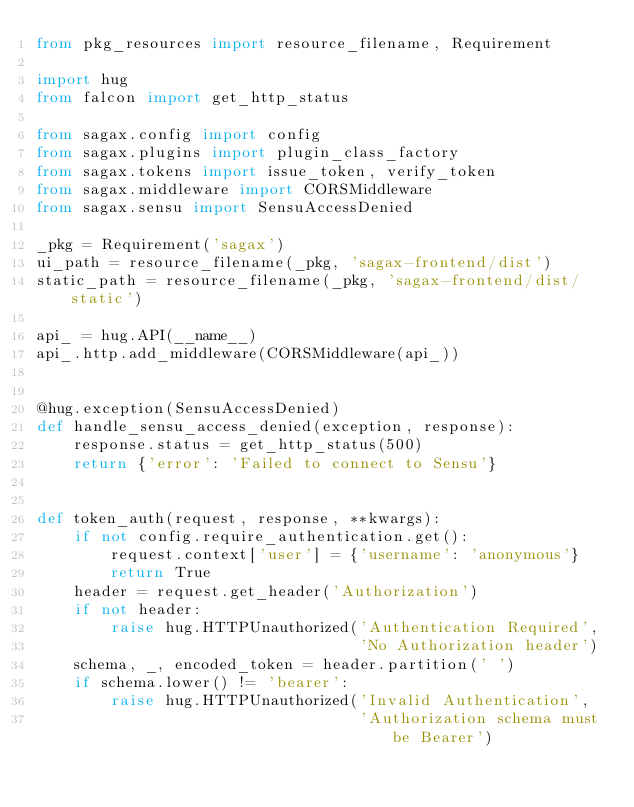Convert code to text. <code><loc_0><loc_0><loc_500><loc_500><_Python_>from pkg_resources import resource_filename, Requirement

import hug
from falcon import get_http_status

from sagax.config import config
from sagax.plugins import plugin_class_factory
from sagax.tokens import issue_token, verify_token
from sagax.middleware import CORSMiddleware
from sagax.sensu import SensuAccessDenied

_pkg = Requirement('sagax')
ui_path = resource_filename(_pkg, 'sagax-frontend/dist')
static_path = resource_filename(_pkg, 'sagax-frontend/dist/static')

api_ = hug.API(__name__)
api_.http.add_middleware(CORSMiddleware(api_))


@hug.exception(SensuAccessDenied)
def handle_sensu_access_denied(exception, response):
    response.status = get_http_status(500)
    return {'error': 'Failed to connect to Sensu'}


def token_auth(request, response, **kwargs):
    if not config.require_authentication.get():
        request.context['user'] = {'username': 'anonymous'}
        return True
    header = request.get_header('Authorization')
    if not header:
        raise hug.HTTPUnauthorized('Authentication Required',
                                   'No Authorization header')
    schema, _, encoded_token = header.partition(' ')
    if schema.lower() != 'bearer':
        raise hug.HTTPUnauthorized('Invalid Authentication',
                                   'Authorization schema must be Bearer')</code> 